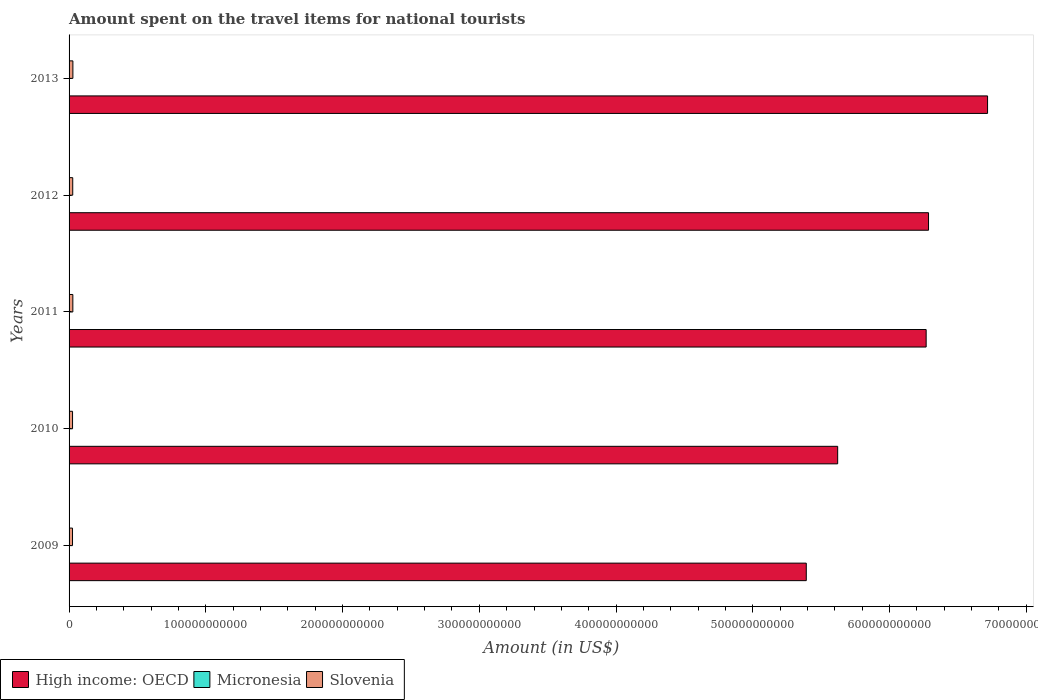How many different coloured bars are there?
Your answer should be very brief. 3. How many groups of bars are there?
Offer a terse response. 5. Are the number of bars per tick equal to the number of legend labels?
Provide a succinct answer. Yes. What is the label of the 1st group of bars from the top?
Your response must be concise. 2013. In how many cases, is the number of bars for a given year not equal to the number of legend labels?
Provide a succinct answer. 0. What is the amount spent on the travel items for national tourists in High income: OECD in 2012?
Offer a terse response. 6.29e+11. Across all years, what is the maximum amount spent on the travel items for national tourists in Slovenia?
Your answer should be compact. 2.79e+09. Across all years, what is the minimum amount spent on the travel items for national tourists in High income: OECD?
Provide a succinct answer. 5.39e+11. In which year was the amount spent on the travel items for national tourists in Slovenia maximum?
Your answer should be very brief. 2013. In which year was the amount spent on the travel items for national tourists in Slovenia minimum?
Offer a terse response. 2009. What is the total amount spent on the travel items for national tourists in Micronesia in the graph?
Provide a succinct answer. 1.14e+08. What is the difference between the amount spent on the travel items for national tourists in High income: OECD in 2010 and that in 2012?
Provide a short and direct response. -6.64e+1. What is the difference between the amount spent on the travel items for national tourists in Slovenia in 2009 and the amount spent on the travel items for national tourists in High income: OECD in 2012?
Ensure brevity in your answer.  -6.26e+11. What is the average amount spent on the travel items for national tourists in Micronesia per year?
Provide a short and direct response. 2.28e+07. In the year 2012, what is the difference between the amount spent on the travel items for national tourists in Micronesia and amount spent on the travel items for national tourists in Slovenia?
Keep it short and to the point. -2.65e+09. In how many years, is the amount spent on the travel items for national tourists in Slovenia greater than 640000000000 US$?
Offer a terse response. 0. What is the ratio of the amount spent on the travel items for national tourists in High income: OECD in 2010 to that in 2012?
Make the answer very short. 0.89. What is the difference between the highest and the second highest amount spent on the travel items for national tourists in Slovenia?
Your answer should be compact. 3.40e+07. What is the difference between the highest and the lowest amount spent on the travel items for national tourists in High income: OECD?
Ensure brevity in your answer.  1.33e+11. In how many years, is the amount spent on the travel items for national tourists in High income: OECD greater than the average amount spent on the travel items for national tourists in High income: OECD taken over all years?
Your response must be concise. 3. What does the 1st bar from the top in 2012 represents?
Offer a terse response. Slovenia. What does the 2nd bar from the bottom in 2011 represents?
Offer a terse response. Micronesia. Is it the case that in every year, the sum of the amount spent on the travel items for national tourists in High income: OECD and amount spent on the travel items for national tourists in Micronesia is greater than the amount spent on the travel items for national tourists in Slovenia?
Offer a terse response. Yes. How many bars are there?
Give a very brief answer. 15. Are all the bars in the graph horizontal?
Keep it short and to the point. Yes. How many years are there in the graph?
Keep it short and to the point. 5. What is the difference between two consecutive major ticks on the X-axis?
Keep it short and to the point. 1.00e+11. Where does the legend appear in the graph?
Provide a succinct answer. Bottom left. How many legend labels are there?
Your response must be concise. 3. How are the legend labels stacked?
Give a very brief answer. Horizontal. What is the title of the graph?
Your answer should be very brief. Amount spent on the travel items for national tourists. What is the label or title of the X-axis?
Give a very brief answer. Amount (in US$). What is the Amount (in US$) in High income: OECD in 2009?
Offer a very short reply. 5.39e+11. What is the Amount (in US$) of Micronesia in 2009?
Provide a succinct answer. 2.20e+07. What is the Amount (in US$) of Slovenia in 2009?
Offer a very short reply. 2.52e+09. What is the Amount (in US$) of High income: OECD in 2010?
Provide a short and direct response. 5.62e+11. What is the Amount (in US$) of Micronesia in 2010?
Provide a short and direct response. 2.40e+07. What is the Amount (in US$) of Slovenia in 2010?
Your answer should be very brief. 2.54e+09. What is the Amount (in US$) of High income: OECD in 2011?
Ensure brevity in your answer.  6.27e+11. What is the Amount (in US$) of Micronesia in 2011?
Your answer should be very brief. 2.20e+07. What is the Amount (in US$) in Slovenia in 2011?
Provide a succinct answer. 2.76e+09. What is the Amount (in US$) of High income: OECD in 2012?
Your answer should be very brief. 6.29e+11. What is the Amount (in US$) in Micronesia in 2012?
Ensure brevity in your answer.  2.20e+07. What is the Amount (in US$) of Slovenia in 2012?
Make the answer very short. 2.67e+09. What is the Amount (in US$) in High income: OECD in 2013?
Keep it short and to the point. 6.72e+11. What is the Amount (in US$) of Micronesia in 2013?
Offer a terse response. 2.40e+07. What is the Amount (in US$) in Slovenia in 2013?
Offer a very short reply. 2.79e+09. Across all years, what is the maximum Amount (in US$) of High income: OECD?
Your response must be concise. 6.72e+11. Across all years, what is the maximum Amount (in US$) of Micronesia?
Your response must be concise. 2.40e+07. Across all years, what is the maximum Amount (in US$) in Slovenia?
Provide a short and direct response. 2.79e+09. Across all years, what is the minimum Amount (in US$) of High income: OECD?
Offer a terse response. 5.39e+11. Across all years, what is the minimum Amount (in US$) in Micronesia?
Your response must be concise. 2.20e+07. Across all years, what is the minimum Amount (in US$) of Slovenia?
Offer a terse response. 2.52e+09. What is the total Amount (in US$) in High income: OECD in the graph?
Your answer should be compact. 3.03e+12. What is the total Amount (in US$) in Micronesia in the graph?
Give a very brief answer. 1.14e+08. What is the total Amount (in US$) in Slovenia in the graph?
Give a very brief answer. 1.33e+1. What is the difference between the Amount (in US$) of High income: OECD in 2009 and that in 2010?
Offer a terse response. -2.29e+1. What is the difference between the Amount (in US$) in Micronesia in 2009 and that in 2010?
Keep it short and to the point. -2.00e+06. What is the difference between the Amount (in US$) of Slovenia in 2009 and that in 2010?
Offer a very short reply. -2.00e+07. What is the difference between the Amount (in US$) of High income: OECD in 2009 and that in 2011?
Your response must be concise. -8.77e+1. What is the difference between the Amount (in US$) in Slovenia in 2009 and that in 2011?
Your answer should be very brief. -2.35e+08. What is the difference between the Amount (in US$) of High income: OECD in 2009 and that in 2012?
Offer a very short reply. -8.94e+1. What is the difference between the Amount (in US$) in Micronesia in 2009 and that in 2012?
Give a very brief answer. 0. What is the difference between the Amount (in US$) in Slovenia in 2009 and that in 2012?
Provide a short and direct response. -1.54e+08. What is the difference between the Amount (in US$) in High income: OECD in 2009 and that in 2013?
Your answer should be compact. -1.33e+11. What is the difference between the Amount (in US$) in Micronesia in 2009 and that in 2013?
Provide a short and direct response. -2.00e+06. What is the difference between the Amount (in US$) in Slovenia in 2009 and that in 2013?
Give a very brief answer. -2.69e+08. What is the difference between the Amount (in US$) in High income: OECD in 2010 and that in 2011?
Give a very brief answer. -6.47e+1. What is the difference between the Amount (in US$) of Slovenia in 2010 and that in 2011?
Offer a terse response. -2.15e+08. What is the difference between the Amount (in US$) in High income: OECD in 2010 and that in 2012?
Your answer should be very brief. -6.64e+1. What is the difference between the Amount (in US$) of Slovenia in 2010 and that in 2012?
Offer a terse response. -1.34e+08. What is the difference between the Amount (in US$) of High income: OECD in 2010 and that in 2013?
Provide a succinct answer. -1.10e+11. What is the difference between the Amount (in US$) in Micronesia in 2010 and that in 2013?
Provide a short and direct response. 0. What is the difference between the Amount (in US$) of Slovenia in 2010 and that in 2013?
Your answer should be compact. -2.49e+08. What is the difference between the Amount (in US$) of High income: OECD in 2011 and that in 2012?
Give a very brief answer. -1.73e+09. What is the difference between the Amount (in US$) in Micronesia in 2011 and that in 2012?
Offer a terse response. 0. What is the difference between the Amount (in US$) in Slovenia in 2011 and that in 2012?
Your answer should be very brief. 8.10e+07. What is the difference between the Amount (in US$) in High income: OECD in 2011 and that in 2013?
Your answer should be very brief. -4.49e+1. What is the difference between the Amount (in US$) of Slovenia in 2011 and that in 2013?
Give a very brief answer. -3.40e+07. What is the difference between the Amount (in US$) in High income: OECD in 2012 and that in 2013?
Ensure brevity in your answer.  -4.32e+1. What is the difference between the Amount (in US$) of Slovenia in 2012 and that in 2013?
Keep it short and to the point. -1.15e+08. What is the difference between the Amount (in US$) of High income: OECD in 2009 and the Amount (in US$) of Micronesia in 2010?
Your answer should be compact. 5.39e+11. What is the difference between the Amount (in US$) of High income: OECD in 2009 and the Amount (in US$) of Slovenia in 2010?
Your answer should be very brief. 5.37e+11. What is the difference between the Amount (in US$) of Micronesia in 2009 and the Amount (in US$) of Slovenia in 2010?
Offer a very short reply. -2.52e+09. What is the difference between the Amount (in US$) in High income: OECD in 2009 and the Amount (in US$) in Micronesia in 2011?
Offer a very short reply. 5.39e+11. What is the difference between the Amount (in US$) of High income: OECD in 2009 and the Amount (in US$) of Slovenia in 2011?
Your answer should be compact. 5.36e+11. What is the difference between the Amount (in US$) of Micronesia in 2009 and the Amount (in US$) of Slovenia in 2011?
Offer a very short reply. -2.73e+09. What is the difference between the Amount (in US$) in High income: OECD in 2009 and the Amount (in US$) in Micronesia in 2012?
Provide a short and direct response. 5.39e+11. What is the difference between the Amount (in US$) of High income: OECD in 2009 and the Amount (in US$) of Slovenia in 2012?
Your answer should be very brief. 5.36e+11. What is the difference between the Amount (in US$) in Micronesia in 2009 and the Amount (in US$) in Slovenia in 2012?
Your response must be concise. -2.65e+09. What is the difference between the Amount (in US$) in High income: OECD in 2009 and the Amount (in US$) in Micronesia in 2013?
Offer a very short reply. 5.39e+11. What is the difference between the Amount (in US$) in High income: OECD in 2009 and the Amount (in US$) in Slovenia in 2013?
Your answer should be compact. 5.36e+11. What is the difference between the Amount (in US$) in Micronesia in 2009 and the Amount (in US$) in Slovenia in 2013?
Offer a very short reply. -2.77e+09. What is the difference between the Amount (in US$) in High income: OECD in 2010 and the Amount (in US$) in Micronesia in 2011?
Provide a succinct answer. 5.62e+11. What is the difference between the Amount (in US$) in High income: OECD in 2010 and the Amount (in US$) in Slovenia in 2011?
Offer a terse response. 5.59e+11. What is the difference between the Amount (in US$) of Micronesia in 2010 and the Amount (in US$) of Slovenia in 2011?
Keep it short and to the point. -2.73e+09. What is the difference between the Amount (in US$) of High income: OECD in 2010 and the Amount (in US$) of Micronesia in 2012?
Offer a very short reply. 5.62e+11. What is the difference between the Amount (in US$) of High income: OECD in 2010 and the Amount (in US$) of Slovenia in 2012?
Ensure brevity in your answer.  5.59e+11. What is the difference between the Amount (in US$) of Micronesia in 2010 and the Amount (in US$) of Slovenia in 2012?
Provide a succinct answer. -2.65e+09. What is the difference between the Amount (in US$) in High income: OECD in 2010 and the Amount (in US$) in Micronesia in 2013?
Your answer should be very brief. 5.62e+11. What is the difference between the Amount (in US$) of High income: OECD in 2010 and the Amount (in US$) of Slovenia in 2013?
Your response must be concise. 5.59e+11. What is the difference between the Amount (in US$) of Micronesia in 2010 and the Amount (in US$) of Slovenia in 2013?
Provide a succinct answer. -2.76e+09. What is the difference between the Amount (in US$) in High income: OECD in 2011 and the Amount (in US$) in Micronesia in 2012?
Make the answer very short. 6.27e+11. What is the difference between the Amount (in US$) of High income: OECD in 2011 and the Amount (in US$) of Slovenia in 2012?
Keep it short and to the point. 6.24e+11. What is the difference between the Amount (in US$) in Micronesia in 2011 and the Amount (in US$) in Slovenia in 2012?
Provide a short and direct response. -2.65e+09. What is the difference between the Amount (in US$) of High income: OECD in 2011 and the Amount (in US$) of Micronesia in 2013?
Ensure brevity in your answer.  6.27e+11. What is the difference between the Amount (in US$) of High income: OECD in 2011 and the Amount (in US$) of Slovenia in 2013?
Make the answer very short. 6.24e+11. What is the difference between the Amount (in US$) in Micronesia in 2011 and the Amount (in US$) in Slovenia in 2013?
Provide a short and direct response. -2.77e+09. What is the difference between the Amount (in US$) of High income: OECD in 2012 and the Amount (in US$) of Micronesia in 2013?
Give a very brief answer. 6.28e+11. What is the difference between the Amount (in US$) in High income: OECD in 2012 and the Amount (in US$) in Slovenia in 2013?
Your response must be concise. 6.26e+11. What is the difference between the Amount (in US$) of Micronesia in 2012 and the Amount (in US$) of Slovenia in 2013?
Make the answer very short. -2.77e+09. What is the average Amount (in US$) of High income: OECD per year?
Your answer should be compact. 6.06e+11. What is the average Amount (in US$) of Micronesia per year?
Your answer should be very brief. 2.28e+07. What is the average Amount (in US$) in Slovenia per year?
Give a very brief answer. 2.66e+09. In the year 2009, what is the difference between the Amount (in US$) in High income: OECD and Amount (in US$) in Micronesia?
Your answer should be very brief. 5.39e+11. In the year 2009, what is the difference between the Amount (in US$) in High income: OECD and Amount (in US$) in Slovenia?
Your answer should be compact. 5.37e+11. In the year 2009, what is the difference between the Amount (in US$) of Micronesia and Amount (in US$) of Slovenia?
Give a very brief answer. -2.50e+09. In the year 2010, what is the difference between the Amount (in US$) in High income: OECD and Amount (in US$) in Micronesia?
Ensure brevity in your answer.  5.62e+11. In the year 2010, what is the difference between the Amount (in US$) of High income: OECD and Amount (in US$) of Slovenia?
Offer a terse response. 5.60e+11. In the year 2010, what is the difference between the Amount (in US$) of Micronesia and Amount (in US$) of Slovenia?
Provide a succinct answer. -2.52e+09. In the year 2011, what is the difference between the Amount (in US$) of High income: OECD and Amount (in US$) of Micronesia?
Make the answer very short. 6.27e+11. In the year 2011, what is the difference between the Amount (in US$) in High income: OECD and Amount (in US$) in Slovenia?
Your response must be concise. 6.24e+11. In the year 2011, what is the difference between the Amount (in US$) of Micronesia and Amount (in US$) of Slovenia?
Offer a terse response. -2.73e+09. In the year 2012, what is the difference between the Amount (in US$) of High income: OECD and Amount (in US$) of Micronesia?
Provide a succinct answer. 6.28e+11. In the year 2012, what is the difference between the Amount (in US$) in High income: OECD and Amount (in US$) in Slovenia?
Your answer should be very brief. 6.26e+11. In the year 2012, what is the difference between the Amount (in US$) in Micronesia and Amount (in US$) in Slovenia?
Offer a very short reply. -2.65e+09. In the year 2013, what is the difference between the Amount (in US$) in High income: OECD and Amount (in US$) in Micronesia?
Offer a terse response. 6.72e+11. In the year 2013, what is the difference between the Amount (in US$) in High income: OECD and Amount (in US$) in Slovenia?
Your answer should be very brief. 6.69e+11. In the year 2013, what is the difference between the Amount (in US$) in Micronesia and Amount (in US$) in Slovenia?
Provide a short and direct response. -2.76e+09. What is the ratio of the Amount (in US$) in High income: OECD in 2009 to that in 2010?
Make the answer very short. 0.96. What is the ratio of the Amount (in US$) in Micronesia in 2009 to that in 2010?
Keep it short and to the point. 0.92. What is the ratio of the Amount (in US$) of High income: OECD in 2009 to that in 2011?
Offer a terse response. 0.86. What is the ratio of the Amount (in US$) in Micronesia in 2009 to that in 2011?
Give a very brief answer. 1. What is the ratio of the Amount (in US$) of Slovenia in 2009 to that in 2011?
Your answer should be compact. 0.91. What is the ratio of the Amount (in US$) in High income: OECD in 2009 to that in 2012?
Keep it short and to the point. 0.86. What is the ratio of the Amount (in US$) of Micronesia in 2009 to that in 2012?
Provide a short and direct response. 1. What is the ratio of the Amount (in US$) in Slovenia in 2009 to that in 2012?
Offer a very short reply. 0.94. What is the ratio of the Amount (in US$) in High income: OECD in 2009 to that in 2013?
Your answer should be very brief. 0.8. What is the ratio of the Amount (in US$) of Slovenia in 2009 to that in 2013?
Provide a succinct answer. 0.9. What is the ratio of the Amount (in US$) in High income: OECD in 2010 to that in 2011?
Provide a succinct answer. 0.9. What is the ratio of the Amount (in US$) of Micronesia in 2010 to that in 2011?
Your answer should be very brief. 1.09. What is the ratio of the Amount (in US$) of Slovenia in 2010 to that in 2011?
Ensure brevity in your answer.  0.92. What is the ratio of the Amount (in US$) of High income: OECD in 2010 to that in 2012?
Offer a very short reply. 0.89. What is the ratio of the Amount (in US$) of Slovenia in 2010 to that in 2012?
Make the answer very short. 0.95. What is the ratio of the Amount (in US$) in High income: OECD in 2010 to that in 2013?
Your answer should be very brief. 0.84. What is the ratio of the Amount (in US$) of Slovenia in 2010 to that in 2013?
Your answer should be compact. 0.91. What is the ratio of the Amount (in US$) in Slovenia in 2011 to that in 2012?
Offer a very short reply. 1.03. What is the ratio of the Amount (in US$) of High income: OECD in 2011 to that in 2013?
Offer a very short reply. 0.93. What is the ratio of the Amount (in US$) in Micronesia in 2011 to that in 2013?
Offer a terse response. 0.92. What is the ratio of the Amount (in US$) of High income: OECD in 2012 to that in 2013?
Offer a very short reply. 0.94. What is the ratio of the Amount (in US$) of Micronesia in 2012 to that in 2013?
Provide a short and direct response. 0.92. What is the ratio of the Amount (in US$) of Slovenia in 2012 to that in 2013?
Offer a very short reply. 0.96. What is the difference between the highest and the second highest Amount (in US$) of High income: OECD?
Ensure brevity in your answer.  4.32e+1. What is the difference between the highest and the second highest Amount (in US$) in Micronesia?
Ensure brevity in your answer.  0. What is the difference between the highest and the second highest Amount (in US$) in Slovenia?
Your answer should be very brief. 3.40e+07. What is the difference between the highest and the lowest Amount (in US$) of High income: OECD?
Make the answer very short. 1.33e+11. What is the difference between the highest and the lowest Amount (in US$) in Slovenia?
Give a very brief answer. 2.69e+08. 